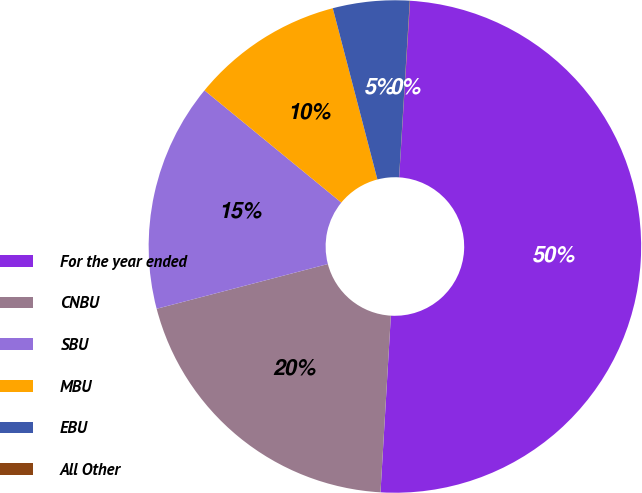Convert chart to OTSL. <chart><loc_0><loc_0><loc_500><loc_500><pie_chart><fcel>For the year ended<fcel>CNBU<fcel>SBU<fcel>MBU<fcel>EBU<fcel>All Other<nl><fcel>49.95%<fcel>20.0%<fcel>15.0%<fcel>10.01%<fcel>5.02%<fcel>0.02%<nl></chart> 